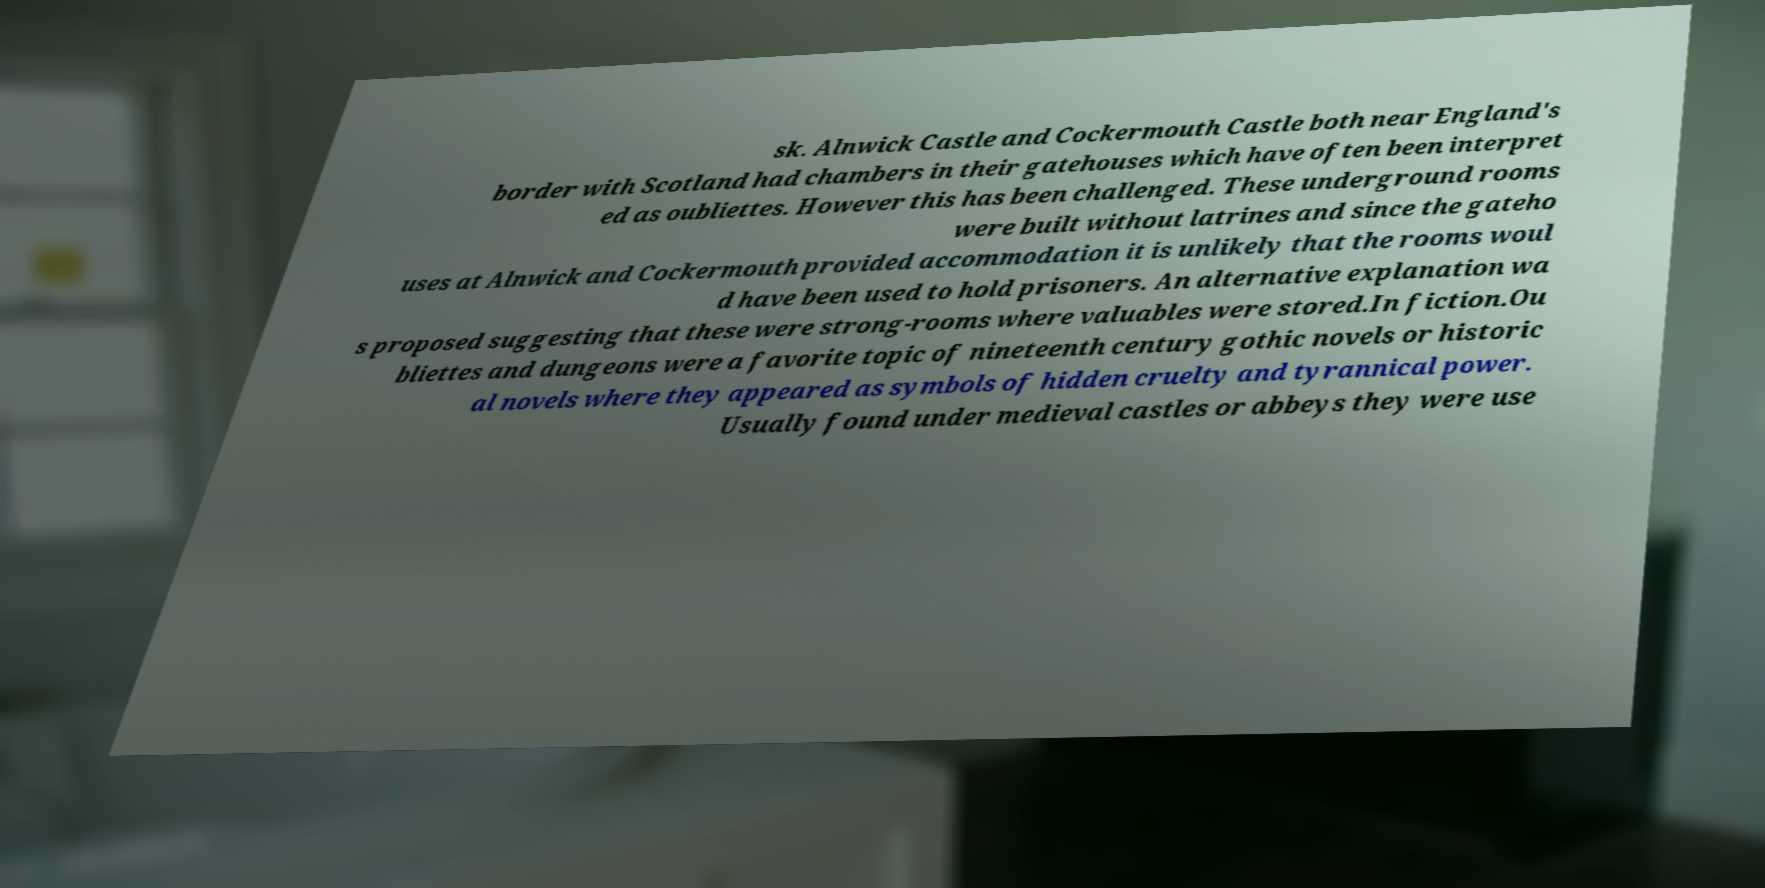For documentation purposes, I need the text within this image transcribed. Could you provide that? sk. Alnwick Castle and Cockermouth Castle both near England's border with Scotland had chambers in their gatehouses which have often been interpret ed as oubliettes. However this has been challenged. These underground rooms were built without latrines and since the gateho uses at Alnwick and Cockermouth provided accommodation it is unlikely that the rooms woul d have been used to hold prisoners. An alternative explanation wa s proposed suggesting that these were strong-rooms where valuables were stored.In fiction.Ou bliettes and dungeons were a favorite topic of nineteenth century gothic novels or historic al novels where they appeared as symbols of hidden cruelty and tyrannical power. Usually found under medieval castles or abbeys they were use 